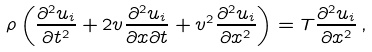<formula> <loc_0><loc_0><loc_500><loc_500>\rho \left ( \frac { \partial ^ { 2 } u _ { i } } { \partial t ^ { 2 } } + 2 v \frac { \partial ^ { 2 } u _ { i } } { \partial x \partial t } + v ^ { 2 } \frac { \partial ^ { 2 } u _ { i } } { \partial x ^ { 2 } } \right ) = T \frac { \partial ^ { 2 } u _ { i } } { \partial x ^ { 2 } } \, ,</formula> 